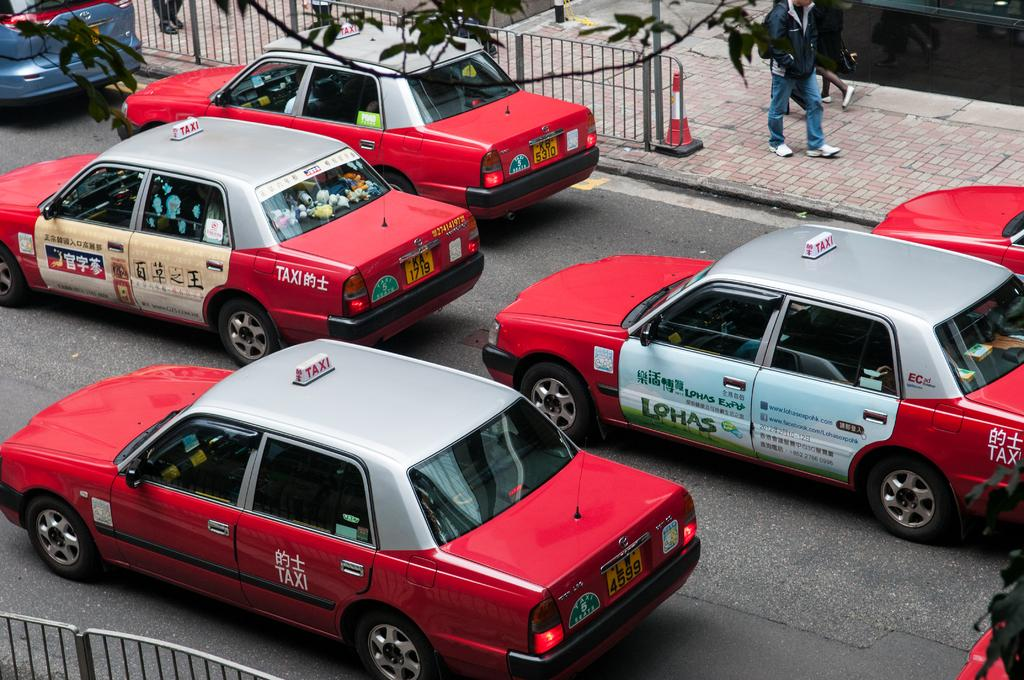<image>
Relay a brief, clear account of the picture shown. a Taxi that is red and white and outside 